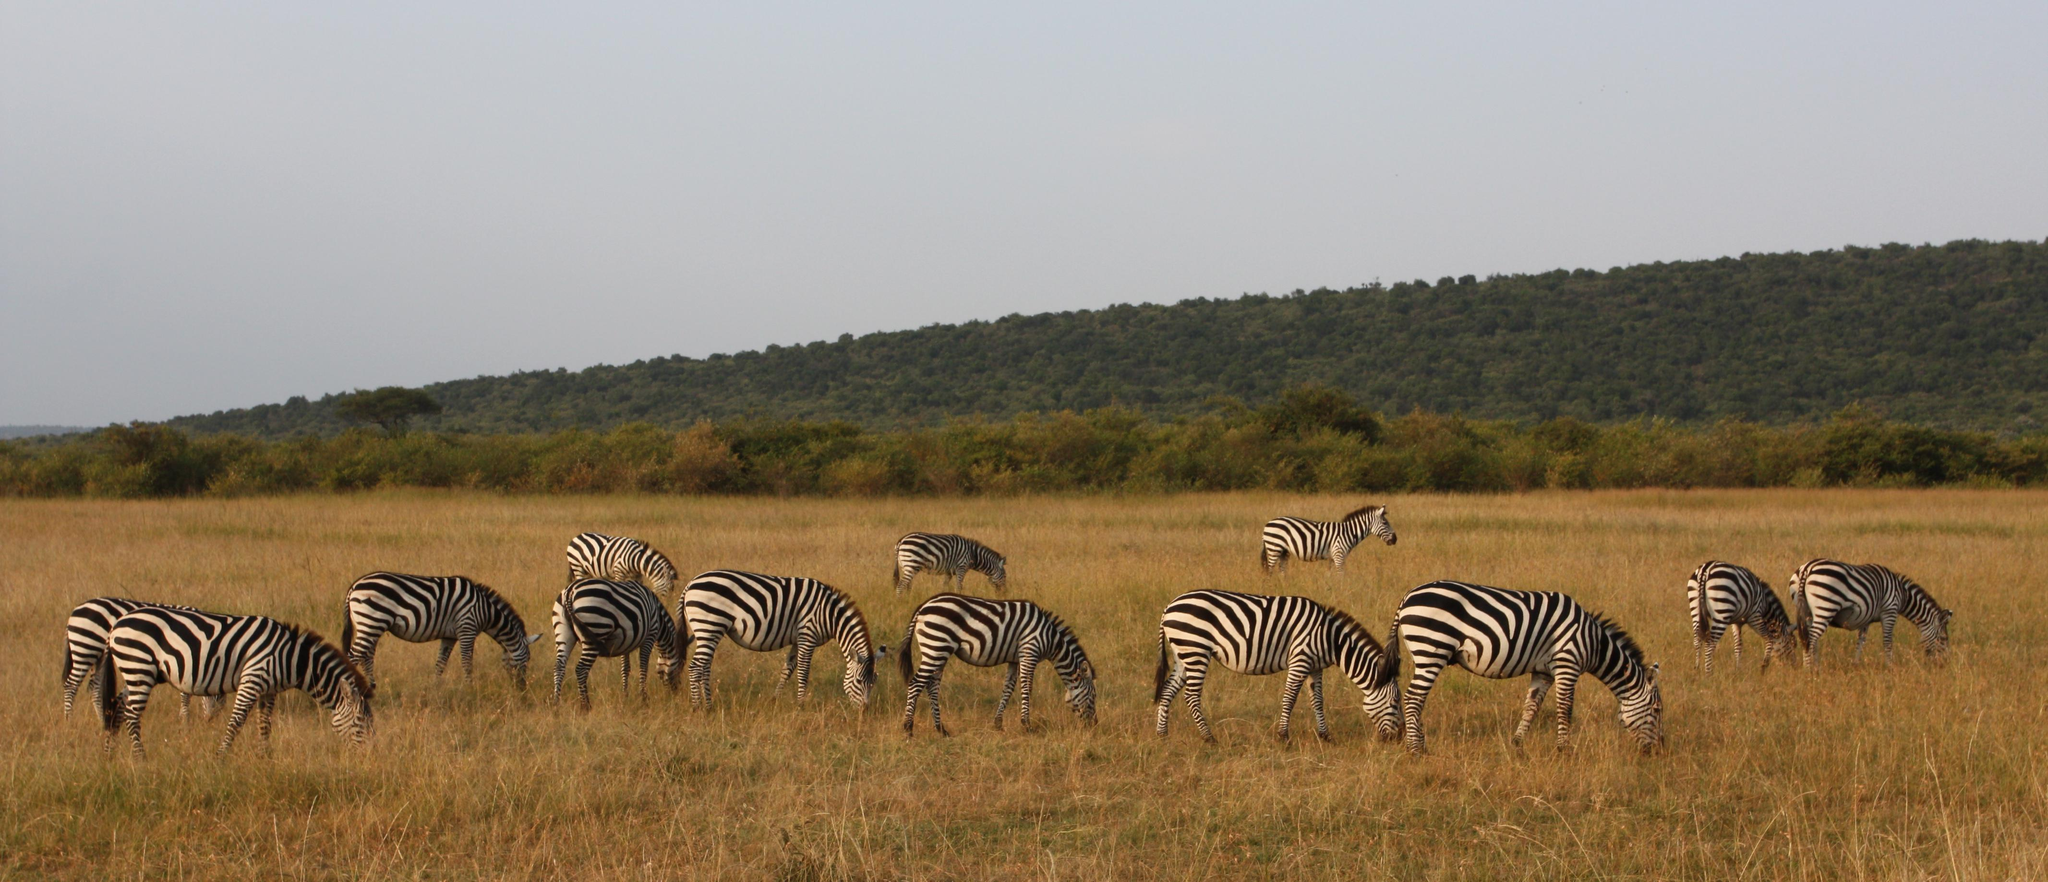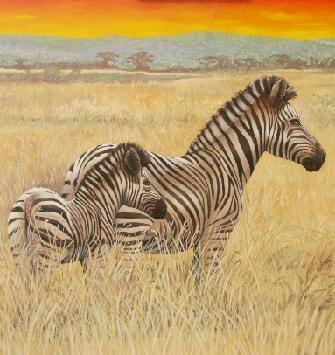The first image is the image on the left, the second image is the image on the right. Given the left and right images, does the statement "The right image contains no more than two zebras." hold true? Answer yes or no. Yes. 